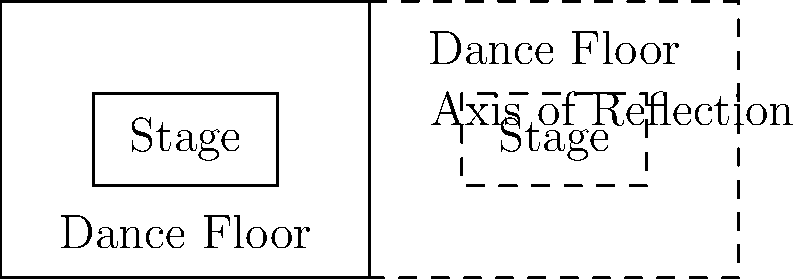As an event organizer, you need to create a symmetrical floor plan for a large venue. The left side of the venue has been designed with a stage and dance floor as shown in the diagram. If you reflect this layout across the vertical axis of reflection, what will be the dimensions of the entire symmetrical venue in terms of the original layout's width and length? To solve this problem, let's follow these steps:

1. Analyze the original layout:
   - The original layout is represented by the solid lines on the left side of the axis of reflection.
   - It has a width of 4 units and a length of 3 units.

2. Understand the reflection process:
   - Reflection across a vertical axis creates a mirror image on the opposite side.
   - The reflected image (dashed lines) is identical in size and shape to the original, but reversed.

3. Determine the new dimensions:
   - Width: The original layout's width (4 units) will be duplicated on the right side of the axis.
     Total width = Original width + Reflected width = 4 + 4 = 8 units
   - Length: The length remains unchanged as we're reflecting across a vertical axis.
     Total length = Original length = 3 units

4. Express the result in terms of the original layout:
   - New width = 2 × (Original width)
   - New length = Original length

Therefore, the dimensions of the entire symmetrical venue will be twice the original width and equal to the original length.
Answer: $2w \times l$, where $w$ is the original width and $l$ is the original length. 